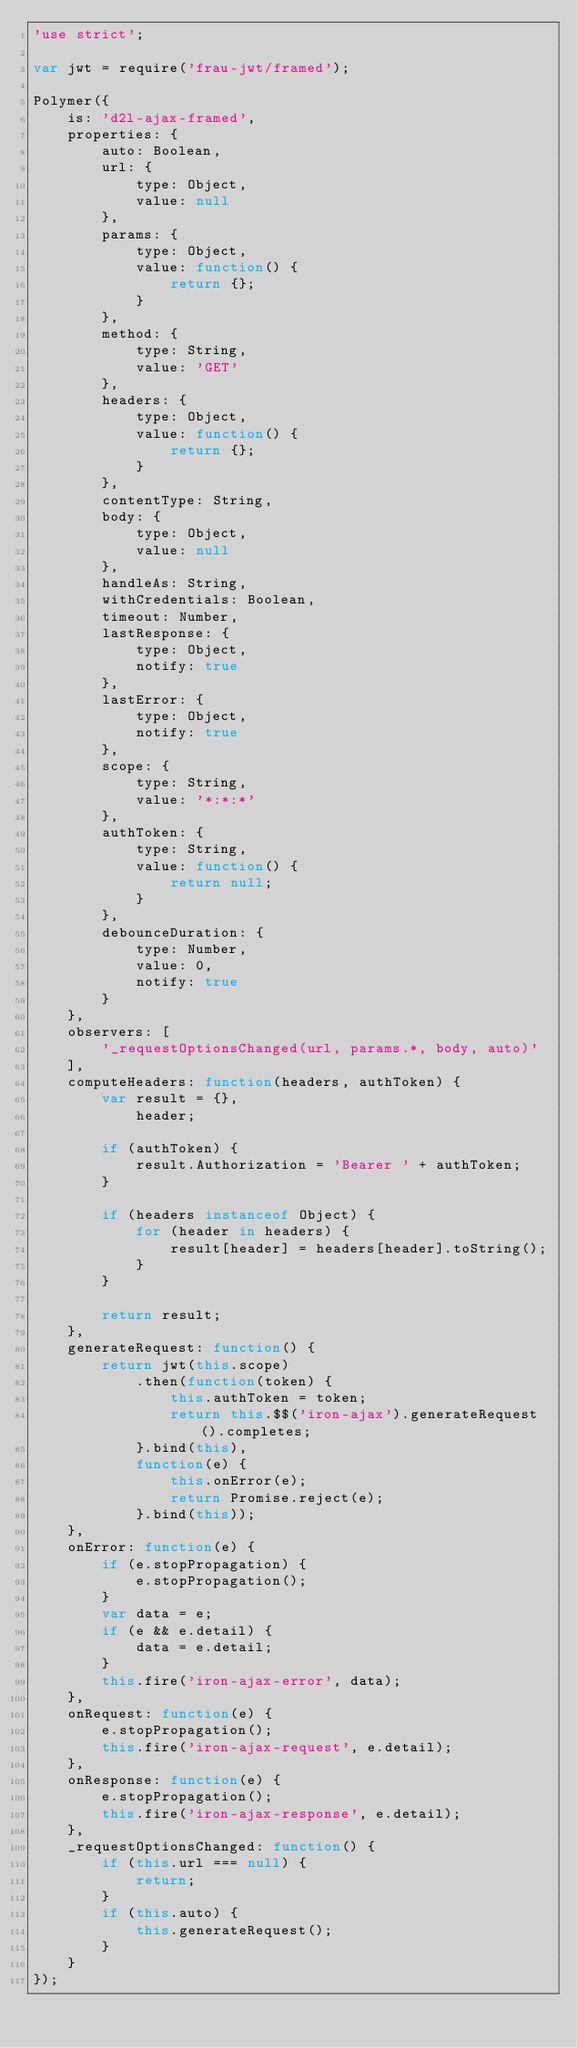Convert code to text. <code><loc_0><loc_0><loc_500><loc_500><_JavaScript_>'use strict';

var jwt = require('frau-jwt/framed');

Polymer({
	is: 'd2l-ajax-framed',
	properties: {
		auto: Boolean,
		url: {
			type: Object,
			value: null
		},
		params: {
			type: Object,
			value: function() {
				return {};
			}
		},
		method: {
			type: String,
			value: 'GET'
		},
		headers: {
			type: Object,
			value: function() {
				return {};
			}
		},
		contentType: String,
		body: {
			type: Object,
			value: null
		},
		handleAs: String,
		withCredentials: Boolean,
		timeout: Number,
		lastResponse: {
			type: Object,
			notify: true
		},
		lastError: {
			type: Object,
			notify: true
		},
		scope: {
			type: String,
			value: '*:*:*'
		},
		authToken: {
			type: String,
			value: function() {
				return null;
			}
		},
		debounceDuration: {
			type: Number,
			value: 0,
			notify: true
		}
	},
	observers: [
		'_requestOptionsChanged(url, params.*, body, auto)'
	],
	computeHeaders: function(headers, authToken) {
		var result = {},
			header;

		if (authToken) {
			result.Authorization = 'Bearer ' + authToken;
		}

		if (headers instanceof Object) {
			for (header in headers) {
				result[header] = headers[header].toString();
			}
		}

		return result;
	},
	generateRequest: function() {
		return jwt(this.scope)
			.then(function(token) {
				this.authToken = token;
				return this.$$('iron-ajax').generateRequest().completes;
			}.bind(this),
			function(e) {
				this.onError(e);
				return Promise.reject(e);
			}.bind(this));
	},
	onError: function(e) {
		if (e.stopPropagation) {
			e.stopPropagation();
		}
		var data = e;
		if (e && e.detail) {
			data = e.detail;
		}
		this.fire('iron-ajax-error', data);
	},
	onRequest: function(e) {
		e.stopPropagation();
		this.fire('iron-ajax-request', e.detail);
	},
	onResponse: function(e) {
		e.stopPropagation();
		this.fire('iron-ajax-response', e.detail);
	},
	_requestOptionsChanged: function() {
		if (this.url === null) {
			return;
		}
		if (this.auto) {
			this.generateRequest();
		}
	}
});
</code> 